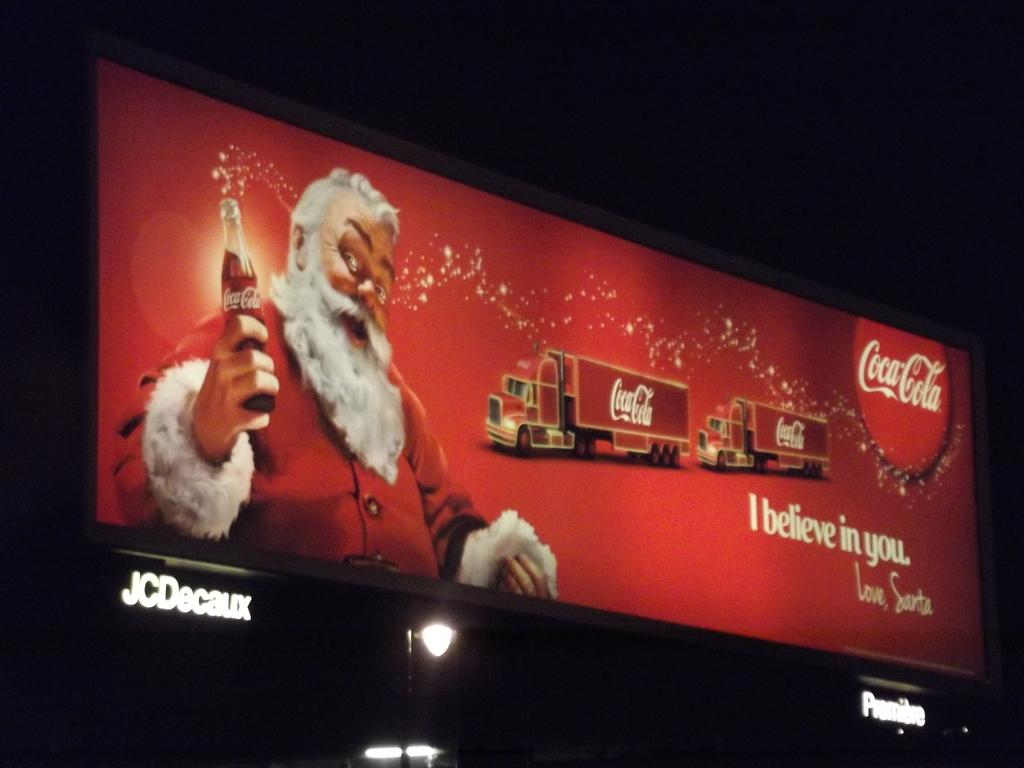<image>
Write a terse but informative summary of the picture. A Coca-Cola holiday billboard showing a picture of Santa. 